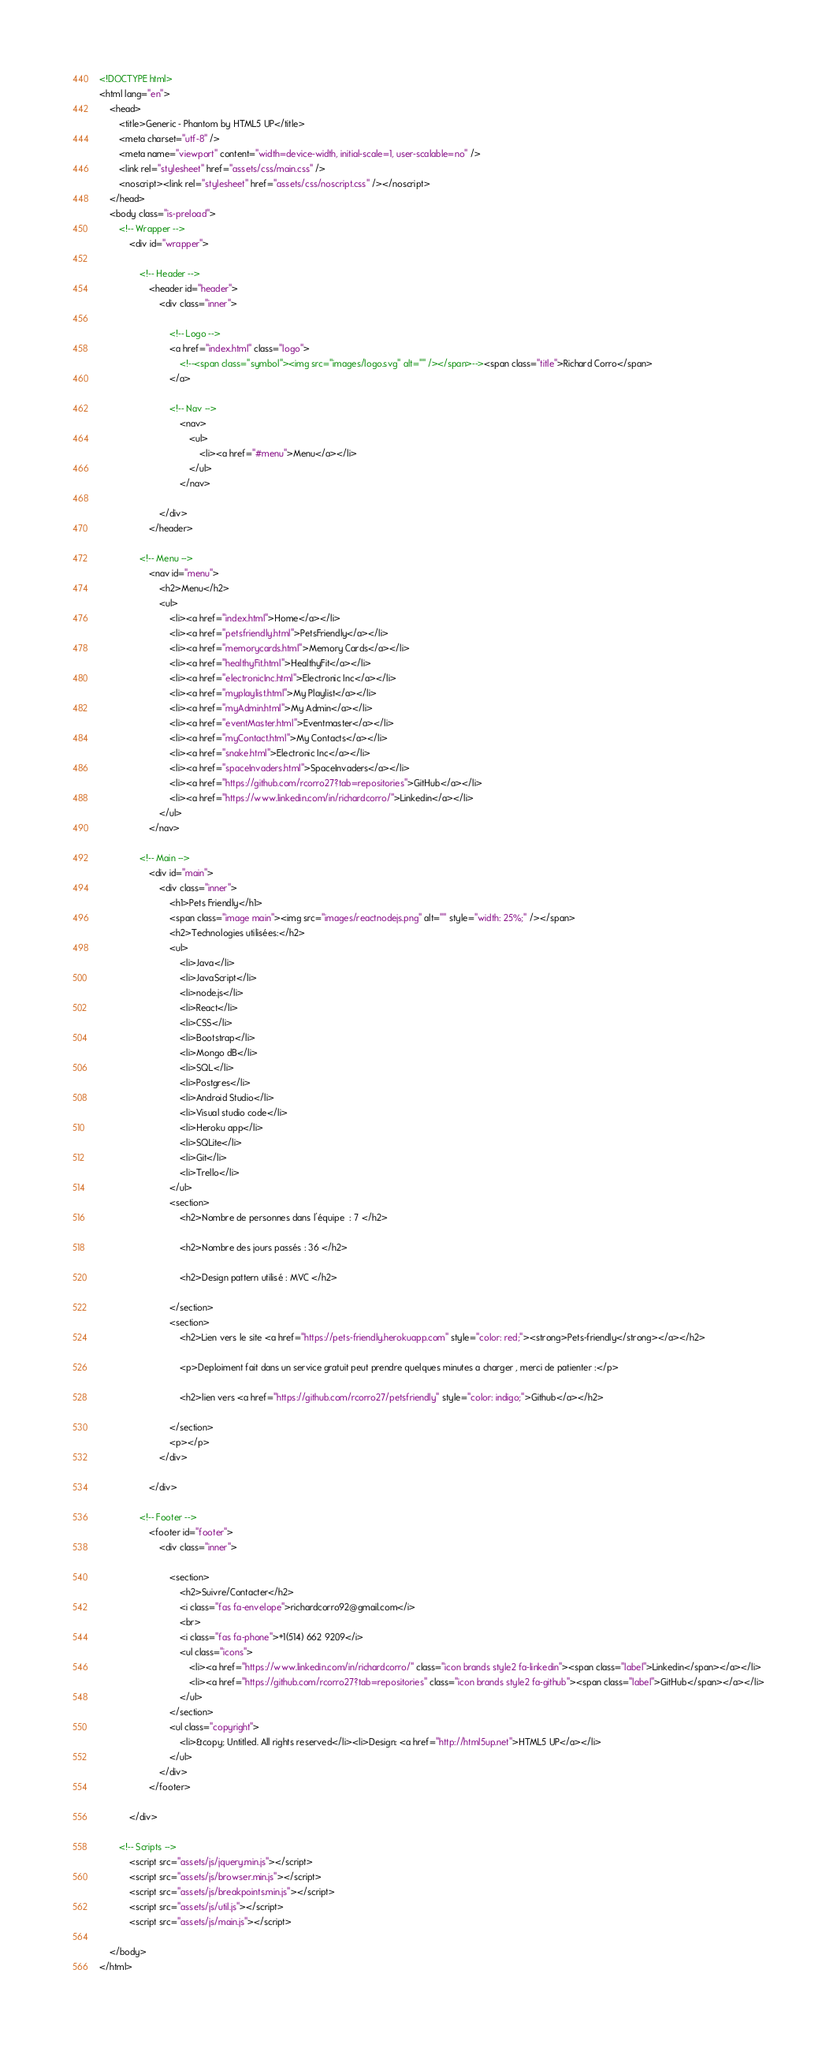<code> <loc_0><loc_0><loc_500><loc_500><_HTML_><!DOCTYPE html>
<html lang="en">
	<head>
		<title>Generic - Phantom by HTML5 UP</title>
		<meta charset="utf-8" />
		<meta name="viewport" content="width=device-width, initial-scale=1, user-scalable=no" />
		<link rel="stylesheet" href="assets/css/main.css" />
		<noscript><link rel="stylesheet" href="assets/css/noscript.css" /></noscript>
	</head>
	<body class="is-preload">
		<!-- Wrapper -->
			<div id="wrapper">

				<!-- Header -->
					<header id="header">
						<div class="inner">

							<!-- Logo -->
							<a href="index.html" class="logo">
                                <!--<span class="symbol"><img src="images/logo.svg" alt="" /></span>--><span class="title">Richard Corro</span>
                            </a>

							<!-- Nav -->
								<nav>
									<ul>
										<li><a href="#menu">Menu</a></li>
									</ul>
								</nav>

						</div>
					</header>

				<!-- Menu -->
					<nav id="menu">
						<h2>Menu</h2>
						<ul>
							<li><a href="index.html">Home</a></li>
							<li><a href="petsfriendly.html">PetsFriendly</a></li>
							<li><a href="memorycards.html">Memory Cards</a></li>
							<li><a href="healthyFit.html">HealthyFit</a></li>
							<li><a href="electronicInc.html">Electronic Inc</a></li>
							<li><a href="myplaylist.html">My Playlist</a></li>
							<li><a href="myAdmin.html">My Admin</a></li>
							<li><a href="eventMaster.html">Eventmaster</a></li>
							<li><a href="myContact.html">My Contacts</a></li>
							<li><a href="snake.html">Electronic Inc</a></li>
							<li><a href="spaceInvaders.html">SpaceInvaders</a></li>
							<li><a href="https://github.com/rcorro27?tab=repositories">GitHub</a></li>
							<li><a href="https://www.linkedin.com/in/richardcorro/">Linkedin</a></li>
						</ul>
					</nav>

				<!-- Main -->
					<div id="main">
						<div class="inner">
							<h1>Pets Friendly</h1>
                            <span class="image main"><img src="images/reactnodejs.png" alt="" style="width: 25%;" /></span>
                            <h2>Technologies utilisées:</h2>
							<ul>
                                <li>Java</li>
                                <li>JavaScript</li>
                                <li>node.js</li>                              
                                <li>React</li>
                                <li>CSS</li>
                                <li>Bootstrap</li>
                                <li>Mongo dB</li>
                                <li>SQL</li>
                                <li>Postgres</li>
                                <li>Android Studio</li>
                                <li>Visual studio code</li>
                                <li>Heroku app</li>
                                <li>SQLite</li>
                                <li>Git</li>
                                <li>Trello</li>
                            </ul>
                            <section>
                                <h2>Nombre de personnes dans l'équipe  : 7 </h2>
                                
                                <h2>Nombre des jours passés : 36 </h2>
								
								<h2>Design pattern utilisé : MVC </h2>
                                
                            </section>
                            <section>
								<h2>Lien vers le site <a href="https://pets-friendly.herokuapp.com" style="color: red;"><strong>Pets-friendly</strong></a></h2>
								
                                <p>Deploiment fait dans un service gratuit peut prendre quelques minutes a charger , merci de patienter :</p>
                                
                                <h2>lien vers <a href="https://github.com/rcorro27/petsfriendly" style="color: indigo;">Github</a></h2>
                               
                            </section>
							<p></p>
                        </div>
                      
					</div>

				<!-- Footer -->
					<footer id="footer">
						<div class="inner">

							<section>
								<h2>Suivre/Contacter</h2>
								<i class="fas fa-envelope">richardcorro92@gmail.com</i>
								<br>
								<i class="fas fa-phone">+1(514) 662 9209</i>
								<ul class="icons">
                                    <li><a href="https://www.linkedin.com/in/richardcorro/" class="icon brands style2 fa-linkedin"><span class="label">Linkedin</span></a></li>
									<li><a href="https://github.com/rcorro27?tab=repositories" class="icon brands style2 fa-github"><span class="label">GitHub</span></a></li>
								</ul>
							</section>
							<ul class="copyright">
								<li>&copy; Untitled. All rights reserved</li><li>Design: <a href="http://html5up.net">HTML5 UP</a></li>
							</ul>
						</div>
					</footer>

			</div>

		<!-- Scripts -->
			<script src="assets/js/jquery.min.js"></script>
			<script src="assets/js/browser.min.js"></script>
			<script src="assets/js/breakpoints.min.js"></script>
			<script src="assets/js/util.js"></script>
			<script src="assets/js/main.js"></script>

	</body>
</html></code> 